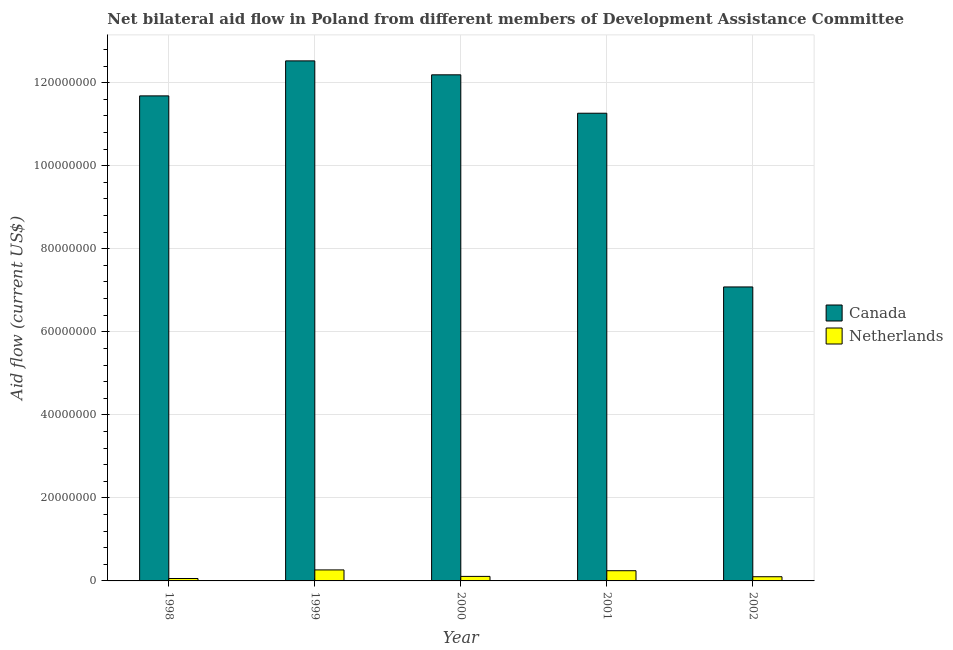Are the number of bars per tick equal to the number of legend labels?
Ensure brevity in your answer.  Yes. Are the number of bars on each tick of the X-axis equal?
Make the answer very short. Yes. How many bars are there on the 1st tick from the left?
Offer a very short reply. 2. How many bars are there on the 5th tick from the right?
Provide a succinct answer. 2. In how many cases, is the number of bars for a given year not equal to the number of legend labels?
Your response must be concise. 0. What is the amount of aid given by netherlands in 2000?
Keep it short and to the point. 1.09e+06. Across all years, what is the maximum amount of aid given by netherlands?
Provide a succinct answer. 2.65e+06. Across all years, what is the minimum amount of aid given by netherlands?
Ensure brevity in your answer.  5.80e+05. In which year was the amount of aid given by canada maximum?
Provide a succinct answer. 1999. In which year was the amount of aid given by canada minimum?
Make the answer very short. 2002. What is the total amount of aid given by canada in the graph?
Offer a very short reply. 5.47e+08. What is the difference between the amount of aid given by canada in 2001 and that in 2002?
Your answer should be compact. 4.18e+07. What is the difference between the amount of aid given by canada in 1998 and the amount of aid given by netherlands in 2002?
Offer a very short reply. 4.60e+07. What is the average amount of aid given by netherlands per year?
Your answer should be very brief. 1.56e+06. In the year 2001, what is the difference between the amount of aid given by canada and amount of aid given by netherlands?
Give a very brief answer. 0. What is the ratio of the amount of aid given by netherlands in 1999 to that in 2002?
Offer a very short reply. 2.62. Is the amount of aid given by netherlands in 2000 less than that in 2001?
Keep it short and to the point. Yes. Is the difference between the amount of aid given by netherlands in 1999 and 2000 greater than the difference between the amount of aid given by canada in 1999 and 2000?
Provide a succinct answer. No. What is the difference between the highest and the lowest amount of aid given by netherlands?
Your response must be concise. 2.07e+06. What does the 2nd bar from the left in 2001 represents?
Provide a succinct answer. Netherlands. How many bars are there?
Your response must be concise. 10. Are all the bars in the graph horizontal?
Offer a terse response. No. How many years are there in the graph?
Offer a terse response. 5. Does the graph contain grids?
Make the answer very short. Yes. How many legend labels are there?
Your response must be concise. 2. What is the title of the graph?
Your response must be concise. Net bilateral aid flow in Poland from different members of Development Assistance Committee. Does "Forest" appear as one of the legend labels in the graph?
Ensure brevity in your answer.  No. What is the label or title of the Y-axis?
Ensure brevity in your answer.  Aid flow (current US$). What is the Aid flow (current US$) in Canada in 1998?
Ensure brevity in your answer.  1.17e+08. What is the Aid flow (current US$) of Netherlands in 1998?
Keep it short and to the point. 5.80e+05. What is the Aid flow (current US$) in Canada in 1999?
Offer a very short reply. 1.25e+08. What is the Aid flow (current US$) of Netherlands in 1999?
Ensure brevity in your answer.  2.65e+06. What is the Aid flow (current US$) in Canada in 2000?
Offer a very short reply. 1.22e+08. What is the Aid flow (current US$) of Netherlands in 2000?
Ensure brevity in your answer.  1.09e+06. What is the Aid flow (current US$) of Canada in 2001?
Offer a very short reply. 1.13e+08. What is the Aid flow (current US$) of Netherlands in 2001?
Ensure brevity in your answer.  2.46e+06. What is the Aid flow (current US$) of Canada in 2002?
Offer a very short reply. 7.08e+07. What is the Aid flow (current US$) in Netherlands in 2002?
Your answer should be very brief. 1.01e+06. Across all years, what is the maximum Aid flow (current US$) of Canada?
Give a very brief answer. 1.25e+08. Across all years, what is the maximum Aid flow (current US$) in Netherlands?
Give a very brief answer. 2.65e+06. Across all years, what is the minimum Aid flow (current US$) in Canada?
Keep it short and to the point. 7.08e+07. Across all years, what is the minimum Aid flow (current US$) of Netherlands?
Offer a very short reply. 5.80e+05. What is the total Aid flow (current US$) of Canada in the graph?
Your answer should be compact. 5.47e+08. What is the total Aid flow (current US$) of Netherlands in the graph?
Your response must be concise. 7.79e+06. What is the difference between the Aid flow (current US$) in Canada in 1998 and that in 1999?
Keep it short and to the point. -8.43e+06. What is the difference between the Aid flow (current US$) in Netherlands in 1998 and that in 1999?
Keep it short and to the point. -2.07e+06. What is the difference between the Aid flow (current US$) of Canada in 1998 and that in 2000?
Make the answer very short. -5.07e+06. What is the difference between the Aid flow (current US$) in Netherlands in 1998 and that in 2000?
Make the answer very short. -5.10e+05. What is the difference between the Aid flow (current US$) in Canada in 1998 and that in 2001?
Offer a very short reply. 4.18e+06. What is the difference between the Aid flow (current US$) of Netherlands in 1998 and that in 2001?
Offer a terse response. -1.88e+06. What is the difference between the Aid flow (current US$) in Canada in 1998 and that in 2002?
Your answer should be compact. 4.60e+07. What is the difference between the Aid flow (current US$) of Netherlands in 1998 and that in 2002?
Offer a terse response. -4.30e+05. What is the difference between the Aid flow (current US$) of Canada in 1999 and that in 2000?
Offer a very short reply. 3.36e+06. What is the difference between the Aid flow (current US$) of Netherlands in 1999 and that in 2000?
Provide a short and direct response. 1.56e+06. What is the difference between the Aid flow (current US$) in Canada in 1999 and that in 2001?
Provide a short and direct response. 1.26e+07. What is the difference between the Aid flow (current US$) of Netherlands in 1999 and that in 2001?
Your answer should be very brief. 1.90e+05. What is the difference between the Aid flow (current US$) of Canada in 1999 and that in 2002?
Ensure brevity in your answer.  5.44e+07. What is the difference between the Aid flow (current US$) of Netherlands in 1999 and that in 2002?
Keep it short and to the point. 1.64e+06. What is the difference between the Aid flow (current US$) in Canada in 2000 and that in 2001?
Give a very brief answer. 9.25e+06. What is the difference between the Aid flow (current US$) of Netherlands in 2000 and that in 2001?
Ensure brevity in your answer.  -1.37e+06. What is the difference between the Aid flow (current US$) in Canada in 2000 and that in 2002?
Keep it short and to the point. 5.11e+07. What is the difference between the Aid flow (current US$) of Netherlands in 2000 and that in 2002?
Provide a succinct answer. 8.00e+04. What is the difference between the Aid flow (current US$) in Canada in 2001 and that in 2002?
Make the answer very short. 4.18e+07. What is the difference between the Aid flow (current US$) in Netherlands in 2001 and that in 2002?
Keep it short and to the point. 1.45e+06. What is the difference between the Aid flow (current US$) in Canada in 1998 and the Aid flow (current US$) in Netherlands in 1999?
Give a very brief answer. 1.14e+08. What is the difference between the Aid flow (current US$) of Canada in 1998 and the Aid flow (current US$) of Netherlands in 2000?
Ensure brevity in your answer.  1.16e+08. What is the difference between the Aid flow (current US$) in Canada in 1998 and the Aid flow (current US$) in Netherlands in 2001?
Provide a succinct answer. 1.14e+08. What is the difference between the Aid flow (current US$) of Canada in 1998 and the Aid flow (current US$) of Netherlands in 2002?
Your answer should be very brief. 1.16e+08. What is the difference between the Aid flow (current US$) in Canada in 1999 and the Aid flow (current US$) in Netherlands in 2000?
Offer a terse response. 1.24e+08. What is the difference between the Aid flow (current US$) of Canada in 1999 and the Aid flow (current US$) of Netherlands in 2001?
Make the answer very short. 1.23e+08. What is the difference between the Aid flow (current US$) in Canada in 1999 and the Aid flow (current US$) in Netherlands in 2002?
Keep it short and to the point. 1.24e+08. What is the difference between the Aid flow (current US$) in Canada in 2000 and the Aid flow (current US$) in Netherlands in 2001?
Offer a very short reply. 1.19e+08. What is the difference between the Aid flow (current US$) of Canada in 2000 and the Aid flow (current US$) of Netherlands in 2002?
Offer a terse response. 1.21e+08. What is the difference between the Aid flow (current US$) in Canada in 2001 and the Aid flow (current US$) in Netherlands in 2002?
Make the answer very short. 1.12e+08. What is the average Aid flow (current US$) in Canada per year?
Provide a short and direct response. 1.09e+08. What is the average Aid flow (current US$) of Netherlands per year?
Keep it short and to the point. 1.56e+06. In the year 1998, what is the difference between the Aid flow (current US$) of Canada and Aid flow (current US$) of Netherlands?
Give a very brief answer. 1.16e+08. In the year 1999, what is the difference between the Aid flow (current US$) of Canada and Aid flow (current US$) of Netherlands?
Offer a terse response. 1.23e+08. In the year 2000, what is the difference between the Aid flow (current US$) of Canada and Aid flow (current US$) of Netherlands?
Your answer should be very brief. 1.21e+08. In the year 2001, what is the difference between the Aid flow (current US$) of Canada and Aid flow (current US$) of Netherlands?
Give a very brief answer. 1.10e+08. In the year 2002, what is the difference between the Aid flow (current US$) in Canada and Aid flow (current US$) in Netherlands?
Keep it short and to the point. 6.98e+07. What is the ratio of the Aid flow (current US$) in Canada in 1998 to that in 1999?
Keep it short and to the point. 0.93. What is the ratio of the Aid flow (current US$) of Netherlands in 1998 to that in 1999?
Provide a short and direct response. 0.22. What is the ratio of the Aid flow (current US$) in Canada in 1998 to that in 2000?
Give a very brief answer. 0.96. What is the ratio of the Aid flow (current US$) in Netherlands in 1998 to that in 2000?
Make the answer very short. 0.53. What is the ratio of the Aid flow (current US$) of Canada in 1998 to that in 2001?
Offer a very short reply. 1.04. What is the ratio of the Aid flow (current US$) of Netherlands in 1998 to that in 2001?
Give a very brief answer. 0.24. What is the ratio of the Aid flow (current US$) in Canada in 1998 to that in 2002?
Ensure brevity in your answer.  1.65. What is the ratio of the Aid flow (current US$) in Netherlands in 1998 to that in 2002?
Provide a short and direct response. 0.57. What is the ratio of the Aid flow (current US$) in Canada in 1999 to that in 2000?
Your answer should be very brief. 1.03. What is the ratio of the Aid flow (current US$) in Netherlands in 1999 to that in 2000?
Keep it short and to the point. 2.43. What is the ratio of the Aid flow (current US$) in Canada in 1999 to that in 2001?
Offer a terse response. 1.11. What is the ratio of the Aid flow (current US$) in Netherlands in 1999 to that in 2001?
Offer a very short reply. 1.08. What is the ratio of the Aid flow (current US$) of Canada in 1999 to that in 2002?
Keep it short and to the point. 1.77. What is the ratio of the Aid flow (current US$) of Netherlands in 1999 to that in 2002?
Provide a succinct answer. 2.62. What is the ratio of the Aid flow (current US$) of Canada in 2000 to that in 2001?
Provide a succinct answer. 1.08. What is the ratio of the Aid flow (current US$) in Netherlands in 2000 to that in 2001?
Your answer should be very brief. 0.44. What is the ratio of the Aid flow (current US$) of Canada in 2000 to that in 2002?
Provide a short and direct response. 1.72. What is the ratio of the Aid flow (current US$) of Netherlands in 2000 to that in 2002?
Keep it short and to the point. 1.08. What is the ratio of the Aid flow (current US$) of Canada in 2001 to that in 2002?
Your answer should be very brief. 1.59. What is the ratio of the Aid flow (current US$) of Netherlands in 2001 to that in 2002?
Offer a very short reply. 2.44. What is the difference between the highest and the second highest Aid flow (current US$) of Canada?
Offer a very short reply. 3.36e+06. What is the difference between the highest and the second highest Aid flow (current US$) of Netherlands?
Give a very brief answer. 1.90e+05. What is the difference between the highest and the lowest Aid flow (current US$) in Canada?
Provide a succinct answer. 5.44e+07. What is the difference between the highest and the lowest Aid flow (current US$) of Netherlands?
Keep it short and to the point. 2.07e+06. 